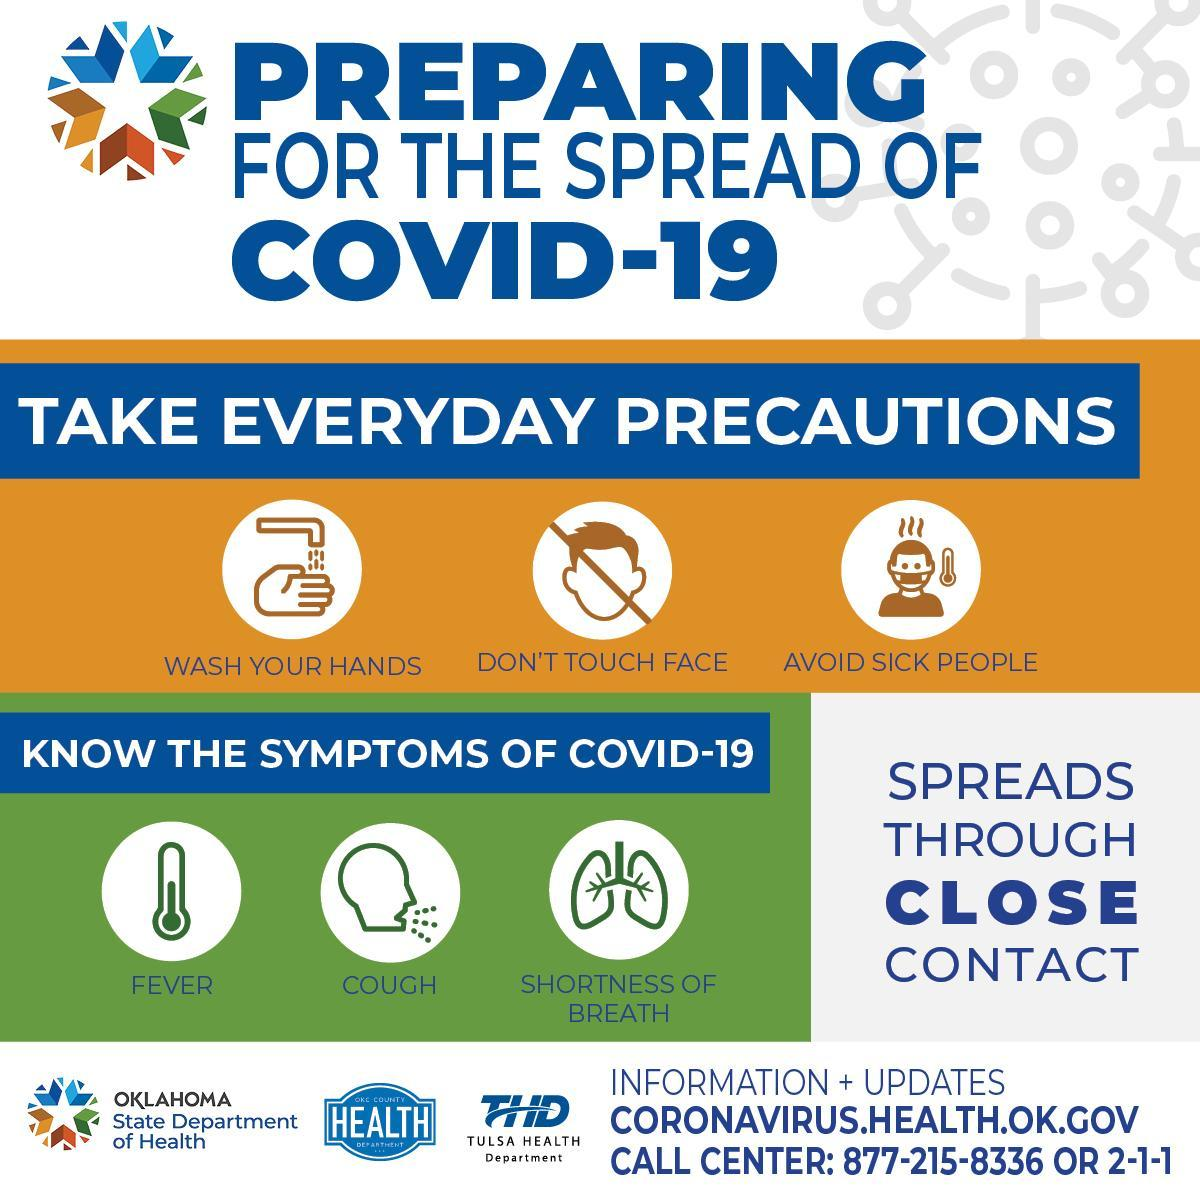What are the symptoms of COVID-19 other than fever & shortness of breath?
Answer the question with a short phrase. COUGH 